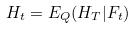<formula> <loc_0><loc_0><loc_500><loc_500>H _ { t } = E _ { Q } ( H _ { T } | F _ { t } )</formula> 